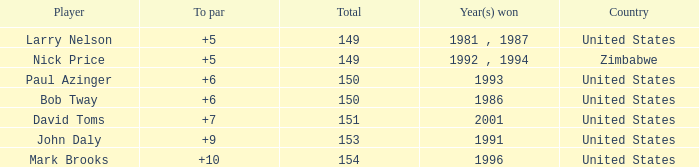Which player won in 1993? Paul Azinger. 